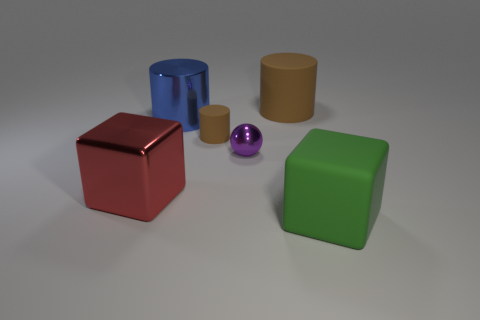Can you tell me which objects in the image are the same color? In the image, no two objects share the exact same color. Each object has a distinct hue, varying from red, blue, and green to metallic purple and brown. 